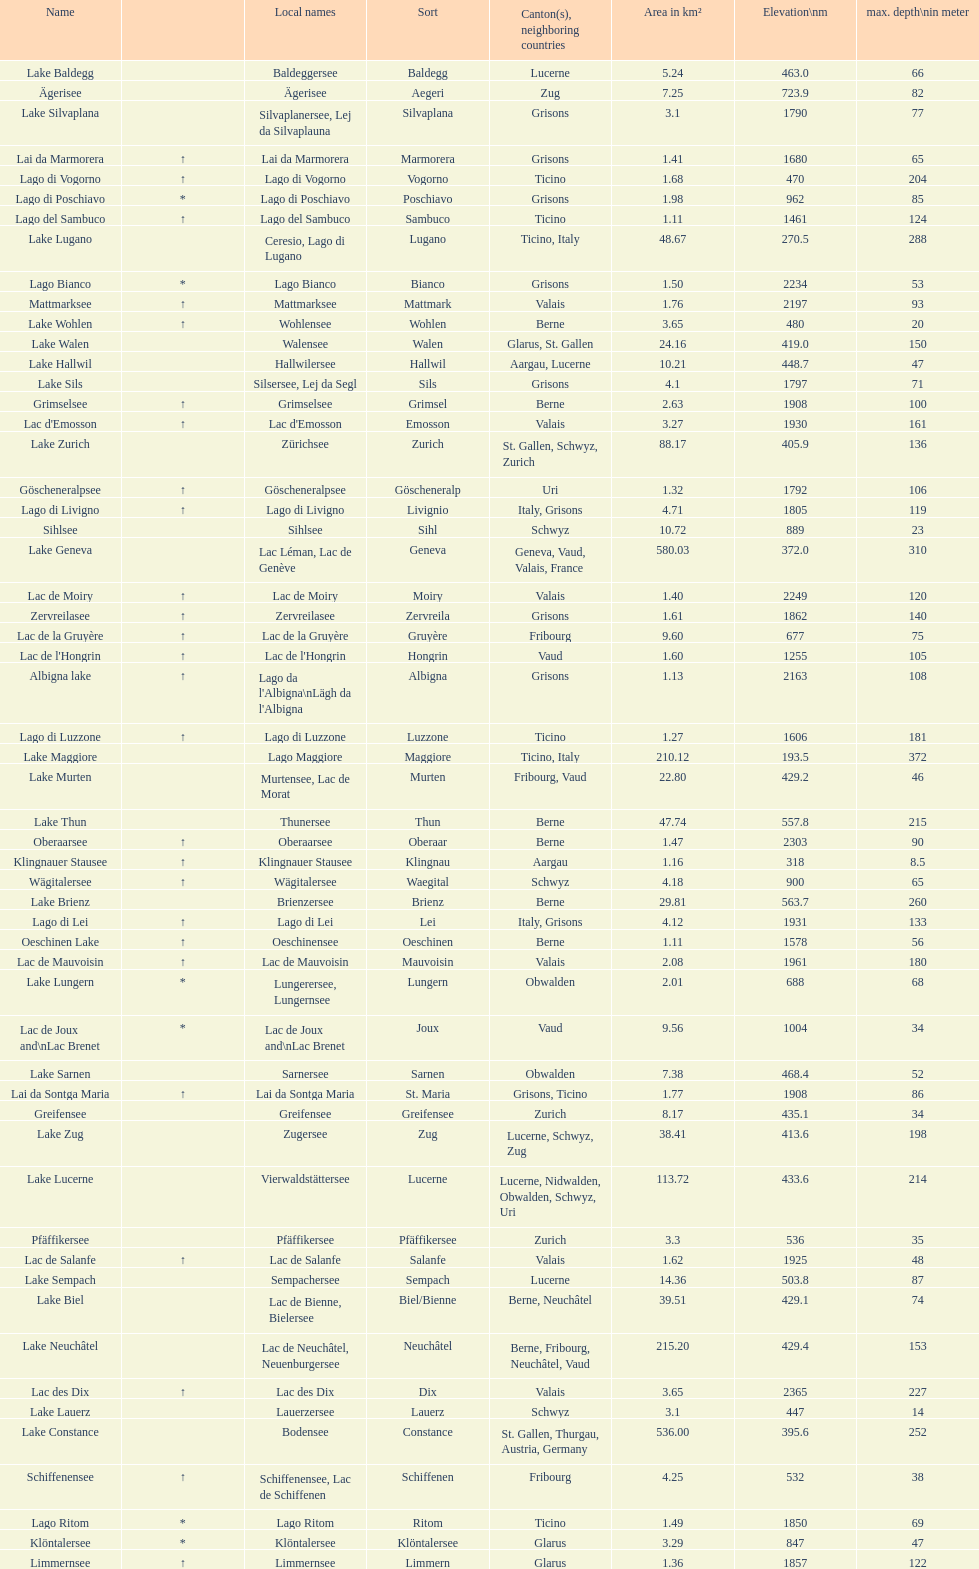What is the combined total depth of the three deepest lakes? 970. 